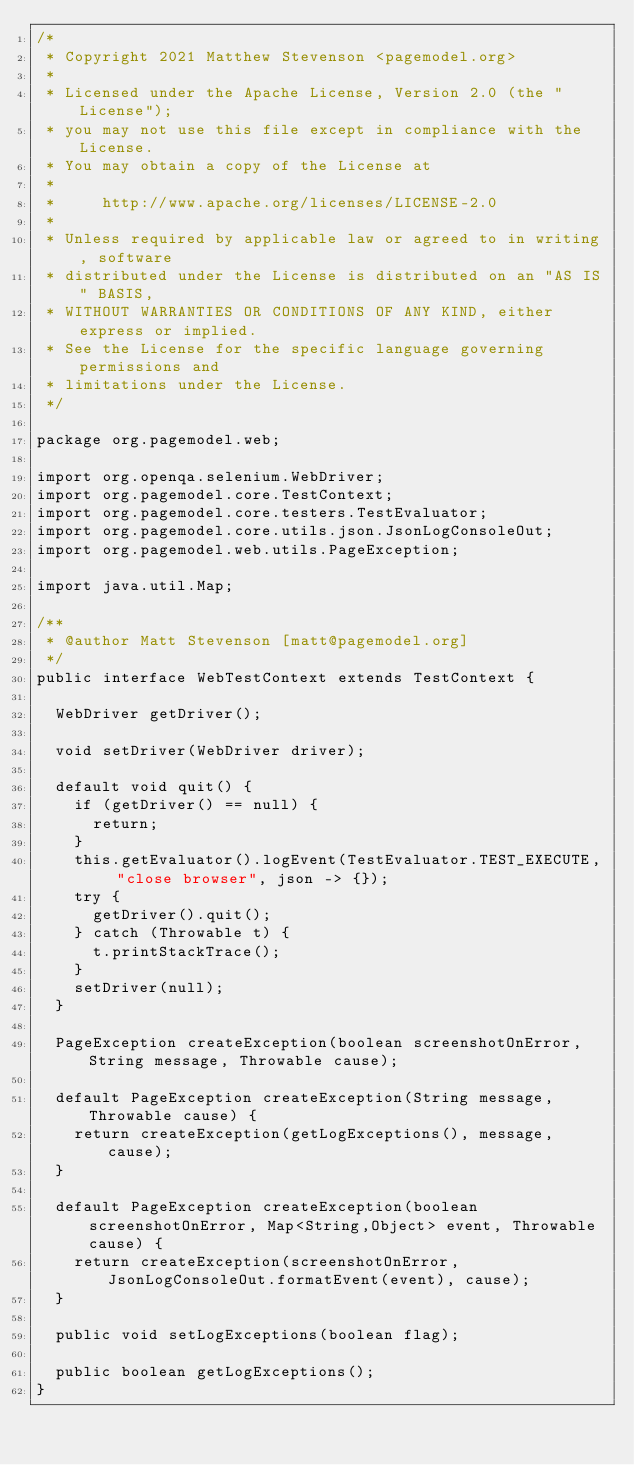<code> <loc_0><loc_0><loc_500><loc_500><_Java_>/*
 * Copyright 2021 Matthew Stevenson <pagemodel.org>
 *
 * Licensed under the Apache License, Version 2.0 (the "License");
 * you may not use this file except in compliance with the License.
 * You may obtain a copy of the License at
 *
 *     http://www.apache.org/licenses/LICENSE-2.0
 *
 * Unless required by applicable law or agreed to in writing, software
 * distributed under the License is distributed on an "AS IS" BASIS,
 * WITHOUT WARRANTIES OR CONDITIONS OF ANY KIND, either express or implied.
 * See the License for the specific language governing permissions and
 * limitations under the License.
 */

package org.pagemodel.web;

import org.openqa.selenium.WebDriver;
import org.pagemodel.core.TestContext;
import org.pagemodel.core.testers.TestEvaluator;
import org.pagemodel.core.utils.json.JsonLogConsoleOut;
import org.pagemodel.web.utils.PageException;

import java.util.Map;

/**
 * @author Matt Stevenson [matt@pagemodel.org]
 */
public interface WebTestContext extends TestContext {

	WebDriver getDriver();

	void setDriver(WebDriver driver);

	default void quit() {
		if (getDriver() == null) {
			return;
		}
		this.getEvaluator().logEvent(TestEvaluator.TEST_EXECUTE, "close browser", json -> {});
		try {
			getDriver().quit();
		} catch (Throwable t) {
			t.printStackTrace();
		}
		setDriver(null);
	}

	PageException createException(boolean screenshotOnError, String message, Throwable cause);

	default PageException createException(String message, Throwable cause) {
		return createException(getLogExceptions(), message, cause);
	}

	default PageException createException(boolean screenshotOnError, Map<String,Object> event, Throwable cause) {
		return createException(screenshotOnError, JsonLogConsoleOut.formatEvent(event), cause);
	}

	public void setLogExceptions(boolean flag);

	public boolean getLogExceptions();
}
</code> 